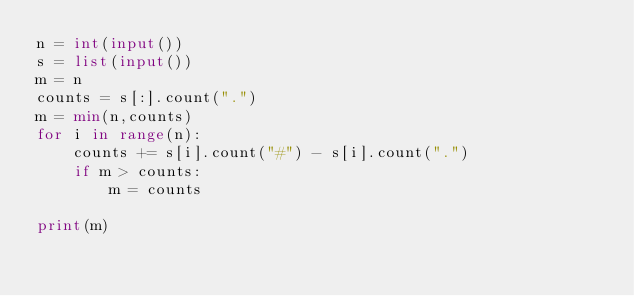Convert code to text. <code><loc_0><loc_0><loc_500><loc_500><_Python_>n = int(input())
s = list(input())
m = n
counts = s[:].count(".")
m = min(n,counts)
for i in range(n):
    counts += s[i].count("#") - s[i].count(".")
    if m > counts:
        m = counts
        
print(m)</code> 